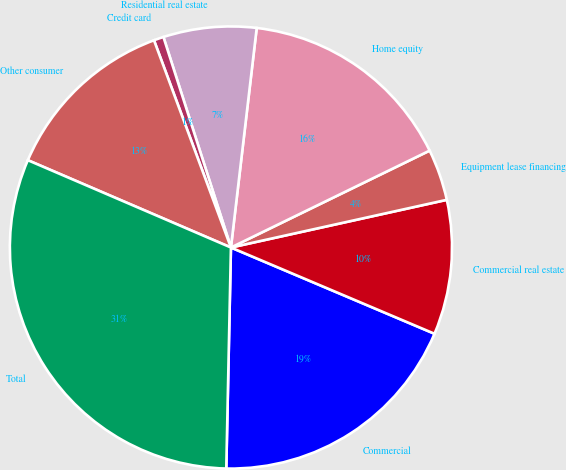Convert chart. <chart><loc_0><loc_0><loc_500><loc_500><pie_chart><fcel>Commercial<fcel>Commercial real estate<fcel>Equipment lease financing<fcel>Home equity<fcel>Residential real estate<fcel>Credit card<fcel>Other consumer<fcel>Total<nl><fcel>18.96%<fcel>9.84%<fcel>3.76%<fcel>15.92%<fcel>6.8%<fcel>0.72%<fcel>12.88%<fcel>31.13%<nl></chart> 